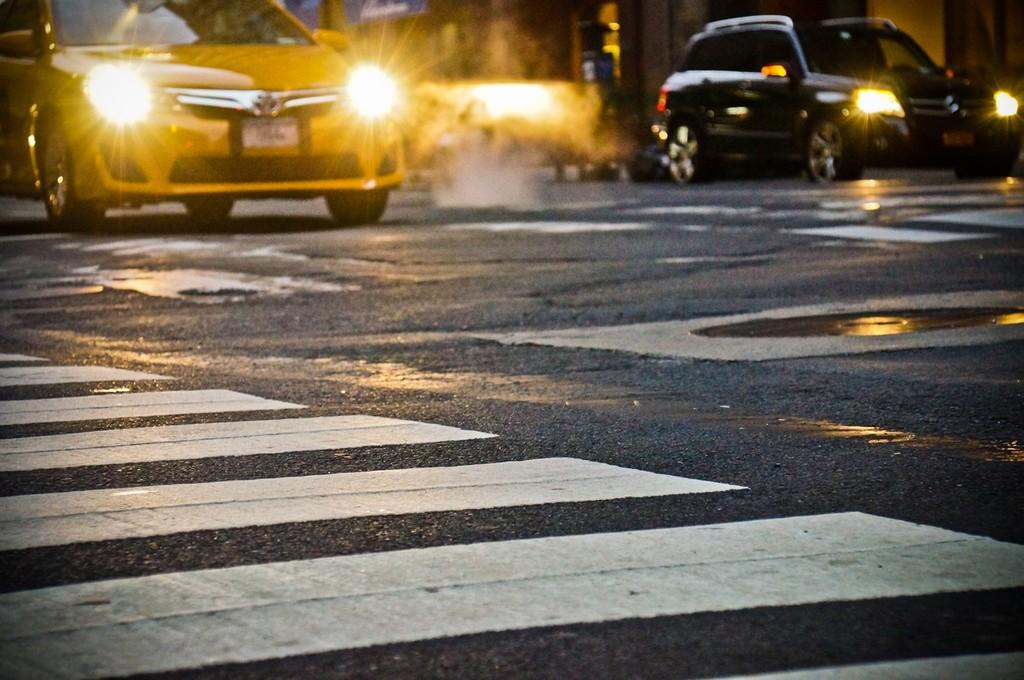What type of vehicles can be seen in the image? There are fleets of cars in the image. What time of day is depicted in the image? The image is taken during night. Where is the image taken? The image is taken on a road. What type of weather can be seen in the image? The provided facts do not mention any weather conditions, so we cannot determine the weather from the image. 